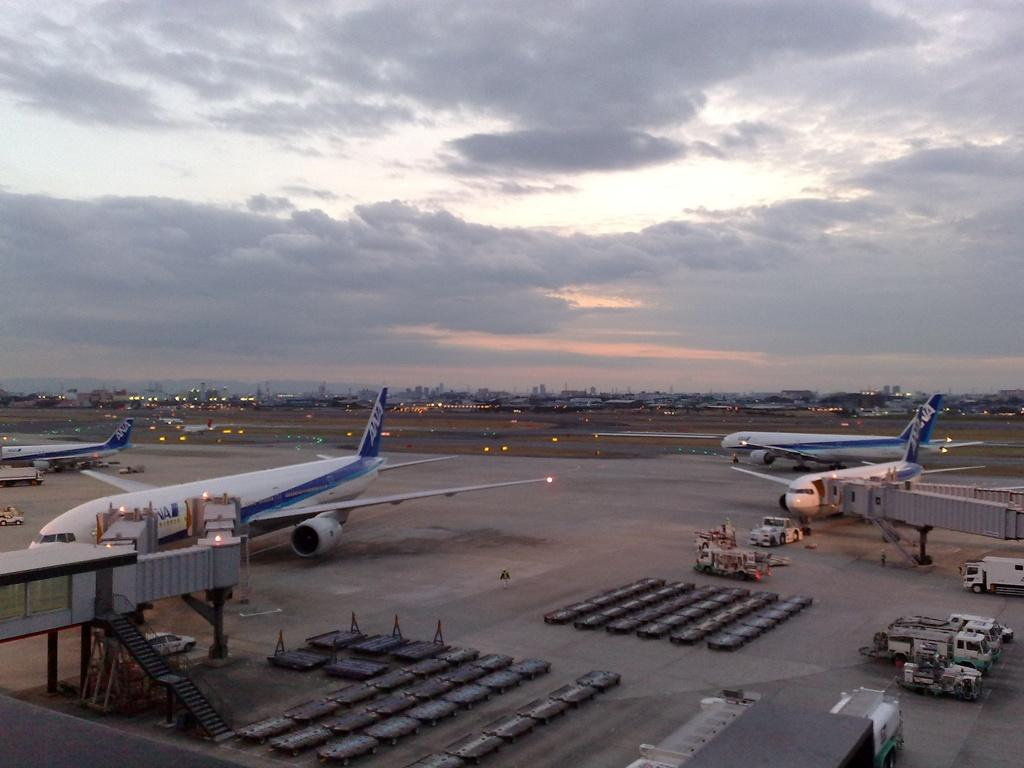What is located at the bottom of the image? There are aircraft on a runway at the bottom of the image. What else can be seen on the runway? There are vehicles on the runway. What can be seen in the background of the image? There are trees, buildings, and lights in the background of the image. What is visible in the sky? There are clouds visible in the sky. How many chairs are visible in the image? There are no chairs present in the image. What type of fact can be determined about the fog in the image? There is no fog present in the image, so no fact about the fog can be determined. 